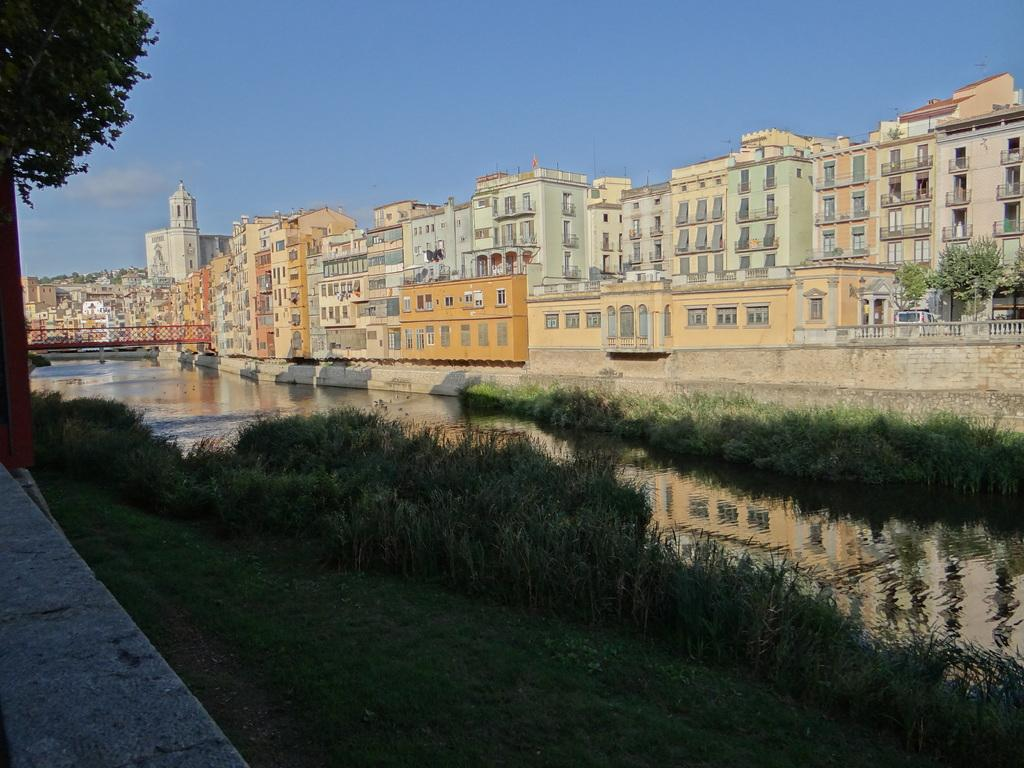What type of structures are visible in the image? There are buildings in the image. What can be seen in front of the buildings? There are trees, a bridge, water, and grass in front of the buildings. What is visible at the top of the image? The sky is visible at the top of the image. Can you tell me how many friends are standing next to the buildings in the image? There is no mention of friends or people in the image; it only features buildings, trees, a bridge, water, grass, and the sky. 